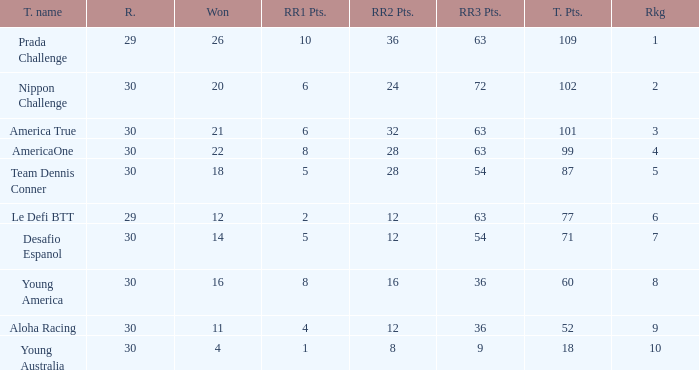Would you be able to parse every entry in this table? {'header': ['T. name', 'R.', 'Won', 'RR1 Pts.', 'RR2 Pts.', 'RR3 Pts.', 'T. Pts.', 'Rkg'], 'rows': [['Prada Challenge', '29', '26', '10', '36', '63', '109', '1'], ['Nippon Challenge', '30', '20', '6', '24', '72', '102', '2'], ['America True', '30', '21', '6', '32', '63', '101', '3'], ['AmericaOne', '30', '22', '8', '28', '63', '99', '4'], ['Team Dennis Conner', '30', '18', '5', '28', '54', '87', '5'], ['Le Defi BTT', '29', '12', '2', '12', '63', '77', '6'], ['Desafio Espanol', '30', '14', '5', '12', '54', '71', '7'], ['Young America', '30', '16', '8', '16', '36', '60', '8'], ['Aloha Racing', '30', '11', '4', '12', '36', '52', '9'], ['Young Australia', '30', '4', '1', '8', '9', '18', '10']]} Name the most rr1 pts for 7 ranking 5.0. 